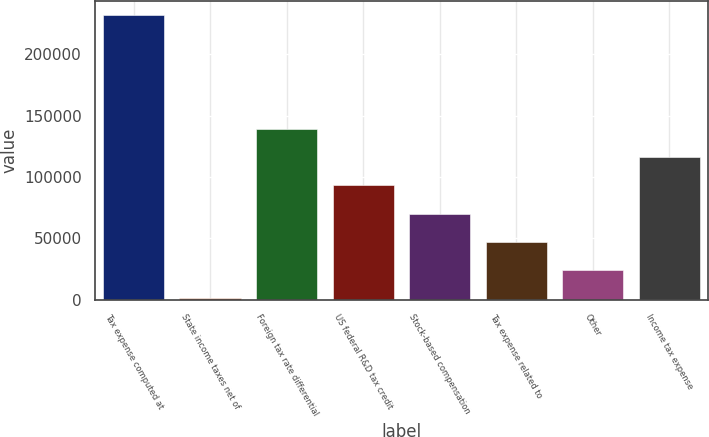Convert chart to OTSL. <chart><loc_0><loc_0><loc_500><loc_500><bar_chart><fcel>Tax expense computed at<fcel>State income taxes net of<fcel>Foreign tax rate differential<fcel>US federal R&D tax credit<fcel>Stock-based compensation<fcel>Tax expense related to<fcel>Other<fcel>Income tax expense<nl><fcel>231714<fcel>1048<fcel>139448<fcel>93314.4<fcel>70247.8<fcel>47181.2<fcel>24114.6<fcel>116381<nl></chart> 